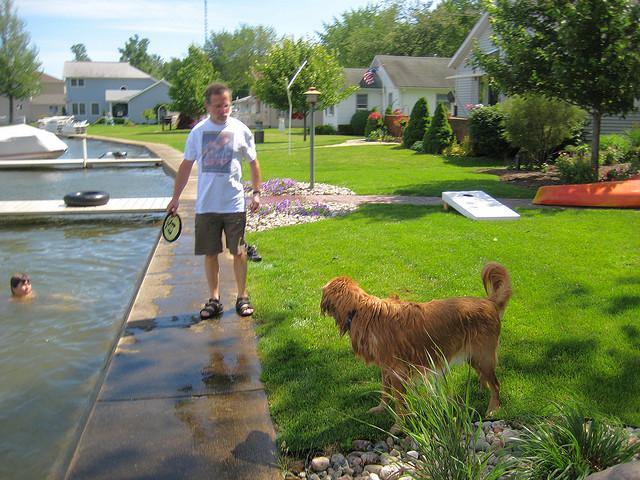Wouldn't you love to walk out your back door and go for a swim?
Be succinct. Yes. Is anyone in the water?
Keep it brief. Yes. Is this a housing complex?
Short answer required. Yes. Does this type of mixed-message attire suggest that this is not in the height of summer or winter?
Keep it brief. No. 